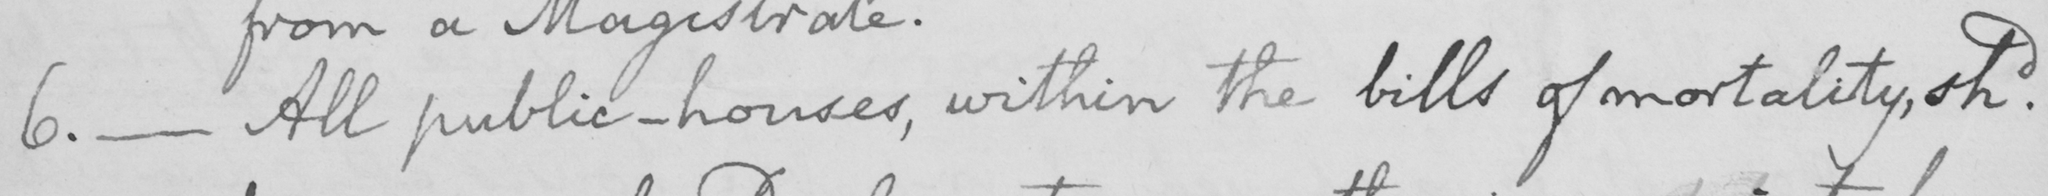Can you tell me what this handwritten text says? 6 .  _  All public-houses , within the bills of mortality , shd . 